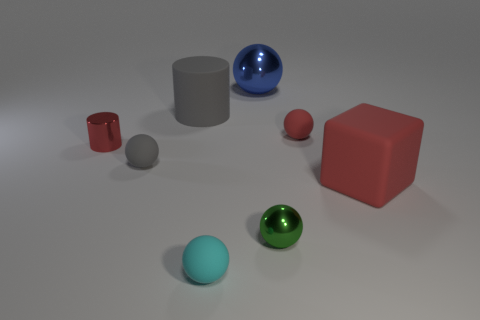Does the tiny shiny cylinder have the same color as the big block?
Your answer should be compact. Yes. What number of other things are there of the same size as the green shiny thing?
Give a very brief answer. 4. Are there the same number of gray rubber things that are behind the tiny metallic cylinder and balls in front of the green object?
Make the answer very short. Yes. What is the color of the large shiny thing that is the same shape as the small cyan rubber thing?
Ensure brevity in your answer.  Blue. Is there any other thing that has the same shape as the big red object?
Your response must be concise. No. Is the color of the small metallic object that is behind the big red object the same as the large rubber cube?
Offer a very short reply. Yes. What size is the blue object that is the same shape as the small red matte thing?
Your answer should be compact. Large. How many tiny gray objects have the same material as the cyan ball?
Provide a succinct answer. 1. There is a gray matte cylinder on the right side of the tiny matte sphere to the left of the gray cylinder; are there any shiny things that are in front of it?
Your response must be concise. Yes. What is the shape of the tiny green metallic thing?
Make the answer very short. Sphere. 